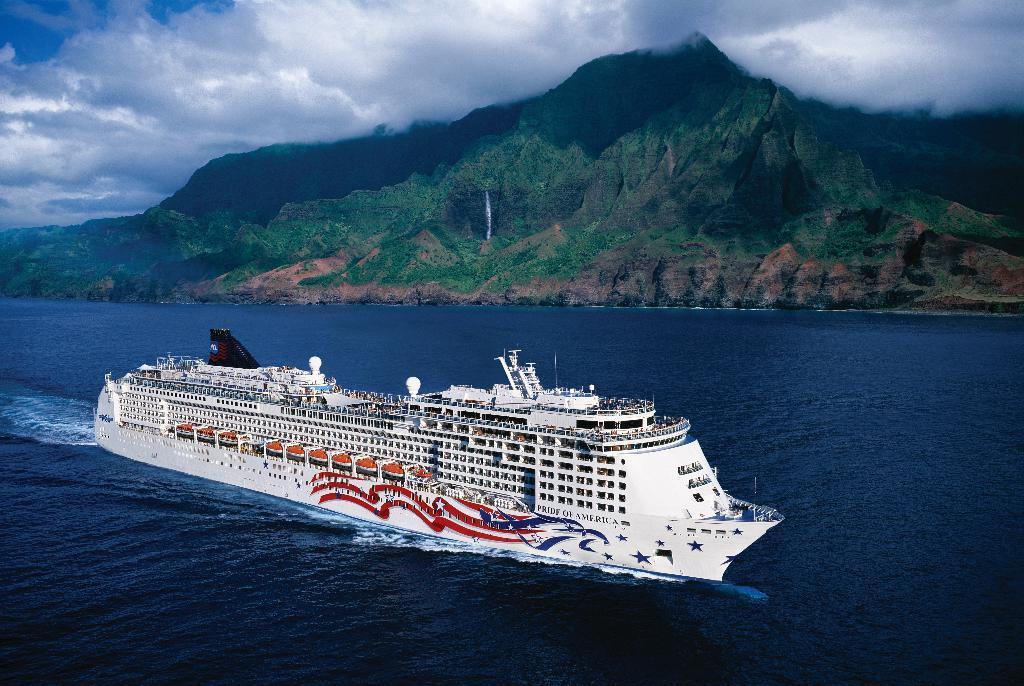What is the main subject of the image? The main subject of the image is a ship. Where is the ship located? The ship is on the water. What can be seen in the background of the image? There are trees, mountains, and plants in the background of the image. What is visible at the top of the image? The sky is visible at the top of the image. What can be observed in the sky? Clouds are present in the sky. How does the ship maintain its balance while standing on one leg in the image? Ships do not stand on one leg; they float on the water. The ship in the image is not depicted as standing on one leg. 